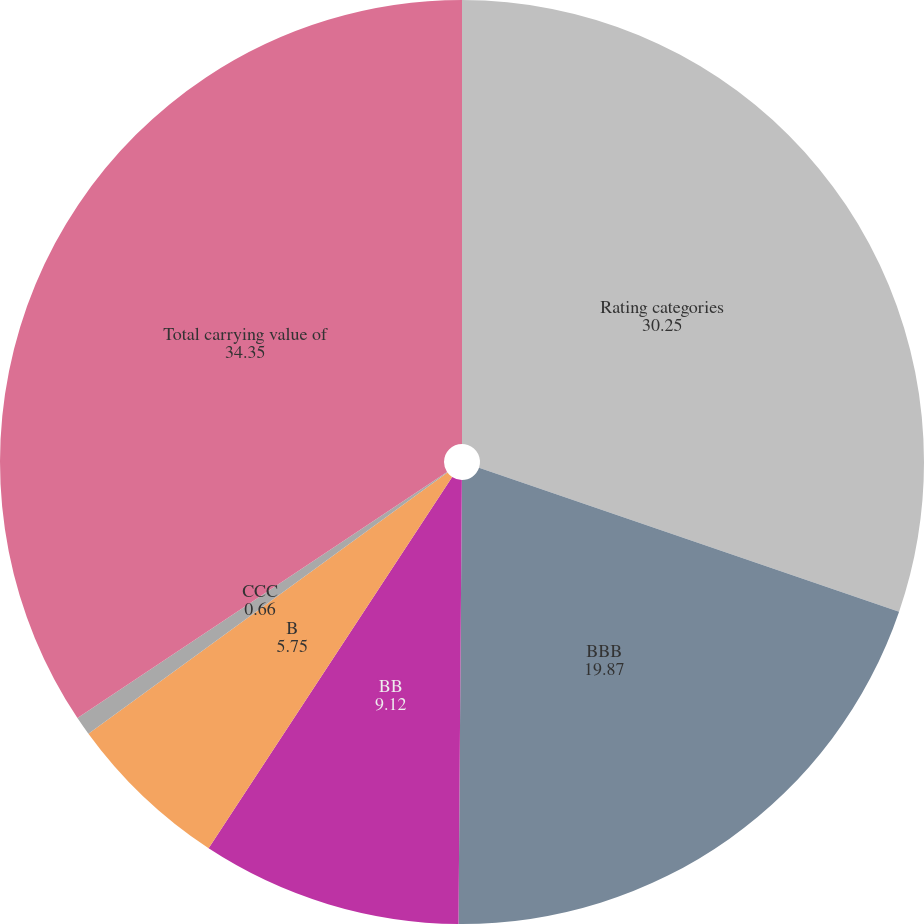Convert chart. <chart><loc_0><loc_0><loc_500><loc_500><pie_chart><fcel>Rating categories<fcel>BBB<fcel>BB<fcel>B<fcel>CCC<fcel>Total carrying value of<nl><fcel>30.25%<fcel>19.87%<fcel>9.12%<fcel>5.75%<fcel>0.66%<fcel>34.35%<nl></chart> 